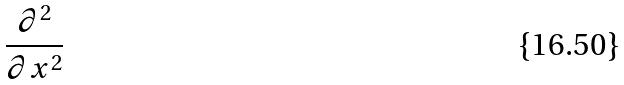<formula> <loc_0><loc_0><loc_500><loc_500>\frac { \partial ^ { 2 } } { \partial x ^ { 2 } }</formula> 